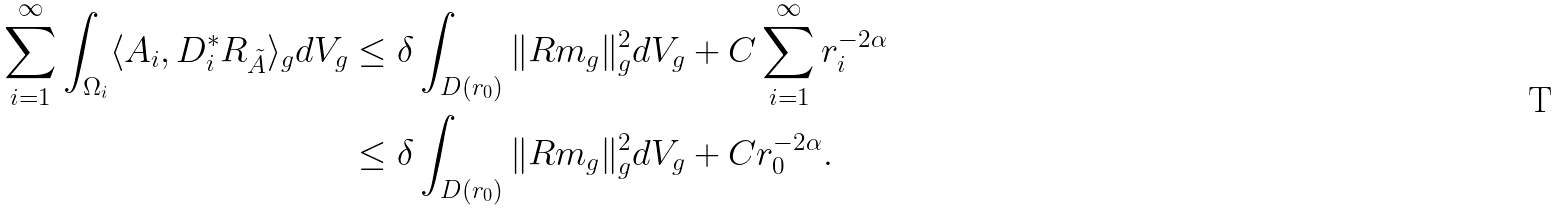Convert formula to latex. <formula><loc_0><loc_0><loc_500><loc_500>\sum _ { i = 1 } ^ { \infty } \int _ { \Omega _ { i } } \langle A _ { i } , D _ { i } ^ { * } R _ { \tilde { A } } \rangle _ { g } d V _ { g } & \leq \delta \int _ { D ( r _ { 0 } ) } \| R m _ { g } \| _ { g } ^ { 2 } d V _ { g } + C \sum _ { i = 1 } ^ { \infty } r _ { i } ^ { - 2 \alpha } \\ & \leq \delta \int _ { D ( r _ { 0 } ) } \| R m _ { g } \| _ { g } ^ { 2 } d V _ { g } + C r _ { 0 } ^ { - 2 \alpha } .</formula> 